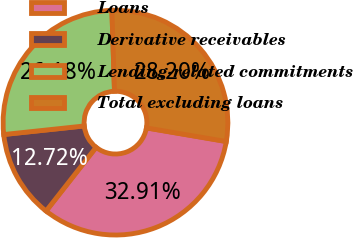Convert chart to OTSL. <chart><loc_0><loc_0><loc_500><loc_500><pie_chart><fcel>Loans<fcel>Derivative receivables<fcel>Lending-related commitments<fcel>Total excluding loans<nl><fcel>32.91%<fcel>12.72%<fcel>26.18%<fcel>28.2%<nl></chart> 